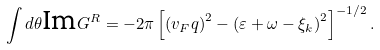<formula> <loc_0><loc_0><loc_500><loc_500>\int d \theta \text {Im} G ^ { R } = - 2 \pi \left [ \left ( v _ { F } q \right ) ^ { 2 } - \left ( \varepsilon + \omega - \xi _ { k } \right ) ^ { 2 } \right ] ^ { - 1 / 2 } .</formula> 